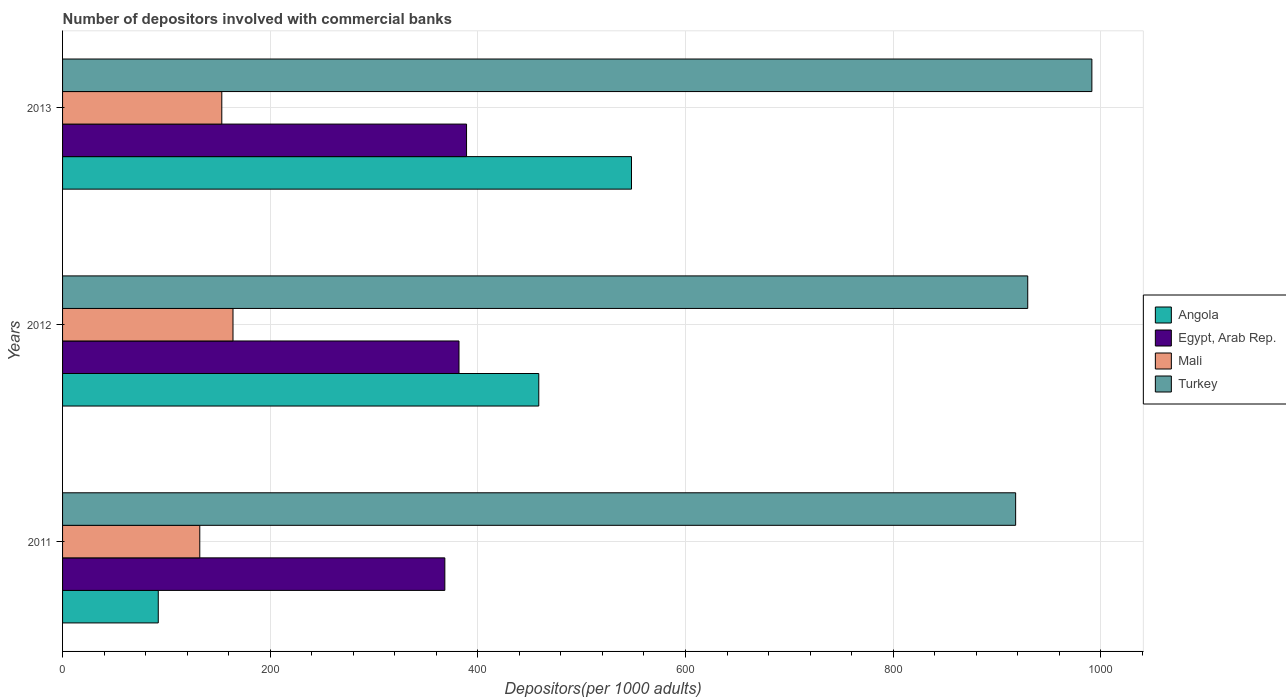How many different coloured bars are there?
Offer a very short reply. 4. How many groups of bars are there?
Provide a short and direct response. 3. Are the number of bars per tick equal to the number of legend labels?
Provide a succinct answer. Yes. In how many cases, is the number of bars for a given year not equal to the number of legend labels?
Keep it short and to the point. 0. What is the number of depositors involved with commercial banks in Angola in 2011?
Your answer should be compact. 92.17. Across all years, what is the maximum number of depositors involved with commercial banks in Mali?
Make the answer very short. 164.15. Across all years, what is the minimum number of depositors involved with commercial banks in Turkey?
Give a very brief answer. 917.97. In which year was the number of depositors involved with commercial banks in Mali maximum?
Your answer should be compact. 2012. What is the total number of depositors involved with commercial banks in Turkey in the graph?
Keep it short and to the point. 2838.98. What is the difference between the number of depositors involved with commercial banks in Mali in 2011 and that in 2013?
Ensure brevity in your answer.  -21.22. What is the difference between the number of depositors involved with commercial banks in Mali in 2011 and the number of depositors involved with commercial banks in Angola in 2012?
Your answer should be compact. -326.53. What is the average number of depositors involved with commercial banks in Mali per year?
Offer a terse response. 149.89. In the year 2011, what is the difference between the number of depositors involved with commercial banks in Mali and number of depositors involved with commercial banks in Angola?
Provide a succinct answer. 39.98. What is the ratio of the number of depositors involved with commercial banks in Turkey in 2012 to that in 2013?
Provide a succinct answer. 0.94. Is the difference between the number of depositors involved with commercial banks in Mali in 2011 and 2012 greater than the difference between the number of depositors involved with commercial banks in Angola in 2011 and 2012?
Your answer should be very brief. Yes. What is the difference between the highest and the second highest number of depositors involved with commercial banks in Mali?
Provide a succinct answer. 10.78. What is the difference between the highest and the lowest number of depositors involved with commercial banks in Angola?
Offer a terse response. 455.8. In how many years, is the number of depositors involved with commercial banks in Turkey greater than the average number of depositors involved with commercial banks in Turkey taken over all years?
Your answer should be very brief. 1. What does the 4th bar from the top in 2011 represents?
Your answer should be very brief. Angola. What does the 2nd bar from the bottom in 2013 represents?
Give a very brief answer. Egypt, Arab Rep. Is it the case that in every year, the sum of the number of depositors involved with commercial banks in Egypt, Arab Rep. and number of depositors involved with commercial banks in Turkey is greater than the number of depositors involved with commercial banks in Angola?
Make the answer very short. Yes. Are all the bars in the graph horizontal?
Offer a terse response. Yes. How many years are there in the graph?
Offer a very short reply. 3. How many legend labels are there?
Ensure brevity in your answer.  4. What is the title of the graph?
Make the answer very short. Number of depositors involved with commercial banks. What is the label or title of the X-axis?
Your response must be concise. Depositors(per 1000 adults). What is the Depositors(per 1000 adults) of Angola in 2011?
Give a very brief answer. 92.17. What is the Depositors(per 1000 adults) of Egypt, Arab Rep. in 2011?
Your response must be concise. 368.19. What is the Depositors(per 1000 adults) of Mali in 2011?
Make the answer very short. 132.15. What is the Depositors(per 1000 adults) in Turkey in 2011?
Offer a very short reply. 917.97. What is the Depositors(per 1000 adults) of Angola in 2012?
Your answer should be very brief. 458.68. What is the Depositors(per 1000 adults) of Egypt, Arab Rep. in 2012?
Your response must be concise. 381.83. What is the Depositors(per 1000 adults) of Mali in 2012?
Provide a short and direct response. 164.15. What is the Depositors(per 1000 adults) of Turkey in 2012?
Your answer should be very brief. 929.62. What is the Depositors(per 1000 adults) in Angola in 2013?
Offer a terse response. 547.97. What is the Depositors(per 1000 adults) in Egypt, Arab Rep. in 2013?
Provide a succinct answer. 389.11. What is the Depositors(per 1000 adults) in Mali in 2013?
Your answer should be compact. 153.37. What is the Depositors(per 1000 adults) of Turkey in 2013?
Make the answer very short. 991.4. Across all years, what is the maximum Depositors(per 1000 adults) of Angola?
Offer a very short reply. 547.97. Across all years, what is the maximum Depositors(per 1000 adults) of Egypt, Arab Rep.?
Give a very brief answer. 389.11. Across all years, what is the maximum Depositors(per 1000 adults) in Mali?
Keep it short and to the point. 164.15. Across all years, what is the maximum Depositors(per 1000 adults) in Turkey?
Ensure brevity in your answer.  991.4. Across all years, what is the minimum Depositors(per 1000 adults) in Angola?
Your answer should be compact. 92.17. Across all years, what is the minimum Depositors(per 1000 adults) of Egypt, Arab Rep.?
Your response must be concise. 368.19. Across all years, what is the minimum Depositors(per 1000 adults) of Mali?
Your answer should be very brief. 132.15. Across all years, what is the minimum Depositors(per 1000 adults) in Turkey?
Your answer should be compact. 917.97. What is the total Depositors(per 1000 adults) in Angola in the graph?
Offer a terse response. 1098.83. What is the total Depositors(per 1000 adults) in Egypt, Arab Rep. in the graph?
Make the answer very short. 1139.13. What is the total Depositors(per 1000 adults) in Mali in the graph?
Provide a succinct answer. 449.68. What is the total Depositors(per 1000 adults) of Turkey in the graph?
Offer a terse response. 2838.98. What is the difference between the Depositors(per 1000 adults) of Angola in 2011 and that in 2012?
Keep it short and to the point. -366.51. What is the difference between the Depositors(per 1000 adults) in Egypt, Arab Rep. in 2011 and that in 2012?
Keep it short and to the point. -13.63. What is the difference between the Depositors(per 1000 adults) of Mali in 2011 and that in 2012?
Your answer should be compact. -32. What is the difference between the Depositors(per 1000 adults) of Turkey in 2011 and that in 2012?
Provide a succinct answer. -11.65. What is the difference between the Depositors(per 1000 adults) of Angola in 2011 and that in 2013?
Your answer should be compact. -455.8. What is the difference between the Depositors(per 1000 adults) in Egypt, Arab Rep. in 2011 and that in 2013?
Provide a succinct answer. -20.91. What is the difference between the Depositors(per 1000 adults) of Mali in 2011 and that in 2013?
Provide a short and direct response. -21.22. What is the difference between the Depositors(per 1000 adults) of Turkey in 2011 and that in 2013?
Provide a succinct answer. -73.43. What is the difference between the Depositors(per 1000 adults) of Angola in 2012 and that in 2013?
Offer a very short reply. -89.29. What is the difference between the Depositors(per 1000 adults) of Egypt, Arab Rep. in 2012 and that in 2013?
Your answer should be compact. -7.28. What is the difference between the Depositors(per 1000 adults) of Mali in 2012 and that in 2013?
Provide a succinct answer. 10.78. What is the difference between the Depositors(per 1000 adults) of Turkey in 2012 and that in 2013?
Your response must be concise. -61.78. What is the difference between the Depositors(per 1000 adults) of Angola in 2011 and the Depositors(per 1000 adults) of Egypt, Arab Rep. in 2012?
Keep it short and to the point. -289.65. What is the difference between the Depositors(per 1000 adults) of Angola in 2011 and the Depositors(per 1000 adults) of Mali in 2012?
Keep it short and to the point. -71.98. What is the difference between the Depositors(per 1000 adults) of Angola in 2011 and the Depositors(per 1000 adults) of Turkey in 2012?
Your answer should be compact. -837.45. What is the difference between the Depositors(per 1000 adults) of Egypt, Arab Rep. in 2011 and the Depositors(per 1000 adults) of Mali in 2012?
Your response must be concise. 204.04. What is the difference between the Depositors(per 1000 adults) of Egypt, Arab Rep. in 2011 and the Depositors(per 1000 adults) of Turkey in 2012?
Provide a short and direct response. -561.43. What is the difference between the Depositors(per 1000 adults) in Mali in 2011 and the Depositors(per 1000 adults) in Turkey in 2012?
Ensure brevity in your answer.  -797.47. What is the difference between the Depositors(per 1000 adults) of Angola in 2011 and the Depositors(per 1000 adults) of Egypt, Arab Rep. in 2013?
Offer a very short reply. -296.93. What is the difference between the Depositors(per 1000 adults) of Angola in 2011 and the Depositors(per 1000 adults) of Mali in 2013?
Provide a short and direct response. -61.2. What is the difference between the Depositors(per 1000 adults) of Angola in 2011 and the Depositors(per 1000 adults) of Turkey in 2013?
Keep it short and to the point. -899.22. What is the difference between the Depositors(per 1000 adults) in Egypt, Arab Rep. in 2011 and the Depositors(per 1000 adults) in Mali in 2013?
Your answer should be compact. 214.82. What is the difference between the Depositors(per 1000 adults) in Egypt, Arab Rep. in 2011 and the Depositors(per 1000 adults) in Turkey in 2013?
Provide a short and direct response. -623.2. What is the difference between the Depositors(per 1000 adults) of Mali in 2011 and the Depositors(per 1000 adults) of Turkey in 2013?
Make the answer very short. -859.24. What is the difference between the Depositors(per 1000 adults) of Angola in 2012 and the Depositors(per 1000 adults) of Egypt, Arab Rep. in 2013?
Provide a succinct answer. 69.58. What is the difference between the Depositors(per 1000 adults) of Angola in 2012 and the Depositors(per 1000 adults) of Mali in 2013?
Ensure brevity in your answer.  305.31. What is the difference between the Depositors(per 1000 adults) in Angola in 2012 and the Depositors(per 1000 adults) in Turkey in 2013?
Provide a succinct answer. -532.71. What is the difference between the Depositors(per 1000 adults) in Egypt, Arab Rep. in 2012 and the Depositors(per 1000 adults) in Mali in 2013?
Offer a very short reply. 228.46. What is the difference between the Depositors(per 1000 adults) in Egypt, Arab Rep. in 2012 and the Depositors(per 1000 adults) in Turkey in 2013?
Offer a terse response. -609.57. What is the difference between the Depositors(per 1000 adults) in Mali in 2012 and the Depositors(per 1000 adults) in Turkey in 2013?
Your response must be concise. -827.24. What is the average Depositors(per 1000 adults) of Angola per year?
Offer a terse response. 366.28. What is the average Depositors(per 1000 adults) of Egypt, Arab Rep. per year?
Provide a succinct answer. 379.71. What is the average Depositors(per 1000 adults) of Mali per year?
Make the answer very short. 149.89. What is the average Depositors(per 1000 adults) of Turkey per year?
Give a very brief answer. 946.33. In the year 2011, what is the difference between the Depositors(per 1000 adults) of Angola and Depositors(per 1000 adults) of Egypt, Arab Rep.?
Provide a short and direct response. -276.02. In the year 2011, what is the difference between the Depositors(per 1000 adults) of Angola and Depositors(per 1000 adults) of Mali?
Offer a terse response. -39.98. In the year 2011, what is the difference between the Depositors(per 1000 adults) of Angola and Depositors(per 1000 adults) of Turkey?
Offer a terse response. -825.79. In the year 2011, what is the difference between the Depositors(per 1000 adults) of Egypt, Arab Rep. and Depositors(per 1000 adults) of Mali?
Offer a terse response. 236.04. In the year 2011, what is the difference between the Depositors(per 1000 adults) of Egypt, Arab Rep. and Depositors(per 1000 adults) of Turkey?
Provide a succinct answer. -549.77. In the year 2011, what is the difference between the Depositors(per 1000 adults) in Mali and Depositors(per 1000 adults) in Turkey?
Offer a terse response. -785.81. In the year 2012, what is the difference between the Depositors(per 1000 adults) of Angola and Depositors(per 1000 adults) of Egypt, Arab Rep.?
Your response must be concise. 76.86. In the year 2012, what is the difference between the Depositors(per 1000 adults) in Angola and Depositors(per 1000 adults) in Mali?
Your answer should be very brief. 294.53. In the year 2012, what is the difference between the Depositors(per 1000 adults) in Angola and Depositors(per 1000 adults) in Turkey?
Your answer should be compact. -470.94. In the year 2012, what is the difference between the Depositors(per 1000 adults) of Egypt, Arab Rep. and Depositors(per 1000 adults) of Mali?
Make the answer very short. 217.67. In the year 2012, what is the difference between the Depositors(per 1000 adults) in Egypt, Arab Rep. and Depositors(per 1000 adults) in Turkey?
Your answer should be compact. -547.79. In the year 2012, what is the difference between the Depositors(per 1000 adults) of Mali and Depositors(per 1000 adults) of Turkey?
Your answer should be compact. -765.47. In the year 2013, what is the difference between the Depositors(per 1000 adults) of Angola and Depositors(per 1000 adults) of Egypt, Arab Rep.?
Offer a very short reply. 158.87. In the year 2013, what is the difference between the Depositors(per 1000 adults) in Angola and Depositors(per 1000 adults) in Mali?
Give a very brief answer. 394.6. In the year 2013, what is the difference between the Depositors(per 1000 adults) in Angola and Depositors(per 1000 adults) in Turkey?
Your answer should be compact. -443.42. In the year 2013, what is the difference between the Depositors(per 1000 adults) in Egypt, Arab Rep. and Depositors(per 1000 adults) in Mali?
Give a very brief answer. 235.73. In the year 2013, what is the difference between the Depositors(per 1000 adults) of Egypt, Arab Rep. and Depositors(per 1000 adults) of Turkey?
Make the answer very short. -602.29. In the year 2013, what is the difference between the Depositors(per 1000 adults) of Mali and Depositors(per 1000 adults) of Turkey?
Keep it short and to the point. -838.02. What is the ratio of the Depositors(per 1000 adults) of Angola in 2011 to that in 2012?
Ensure brevity in your answer.  0.2. What is the ratio of the Depositors(per 1000 adults) in Mali in 2011 to that in 2012?
Provide a short and direct response. 0.81. What is the ratio of the Depositors(per 1000 adults) in Turkey in 2011 to that in 2012?
Provide a short and direct response. 0.99. What is the ratio of the Depositors(per 1000 adults) in Angola in 2011 to that in 2013?
Provide a succinct answer. 0.17. What is the ratio of the Depositors(per 1000 adults) of Egypt, Arab Rep. in 2011 to that in 2013?
Ensure brevity in your answer.  0.95. What is the ratio of the Depositors(per 1000 adults) of Mali in 2011 to that in 2013?
Provide a succinct answer. 0.86. What is the ratio of the Depositors(per 1000 adults) in Turkey in 2011 to that in 2013?
Make the answer very short. 0.93. What is the ratio of the Depositors(per 1000 adults) of Angola in 2012 to that in 2013?
Your answer should be compact. 0.84. What is the ratio of the Depositors(per 1000 adults) of Egypt, Arab Rep. in 2012 to that in 2013?
Keep it short and to the point. 0.98. What is the ratio of the Depositors(per 1000 adults) of Mali in 2012 to that in 2013?
Offer a terse response. 1.07. What is the ratio of the Depositors(per 1000 adults) of Turkey in 2012 to that in 2013?
Give a very brief answer. 0.94. What is the difference between the highest and the second highest Depositors(per 1000 adults) of Angola?
Offer a terse response. 89.29. What is the difference between the highest and the second highest Depositors(per 1000 adults) of Egypt, Arab Rep.?
Make the answer very short. 7.28. What is the difference between the highest and the second highest Depositors(per 1000 adults) in Mali?
Ensure brevity in your answer.  10.78. What is the difference between the highest and the second highest Depositors(per 1000 adults) in Turkey?
Give a very brief answer. 61.78. What is the difference between the highest and the lowest Depositors(per 1000 adults) in Angola?
Offer a terse response. 455.8. What is the difference between the highest and the lowest Depositors(per 1000 adults) in Egypt, Arab Rep.?
Your answer should be very brief. 20.91. What is the difference between the highest and the lowest Depositors(per 1000 adults) of Mali?
Your answer should be compact. 32. What is the difference between the highest and the lowest Depositors(per 1000 adults) of Turkey?
Your answer should be very brief. 73.43. 